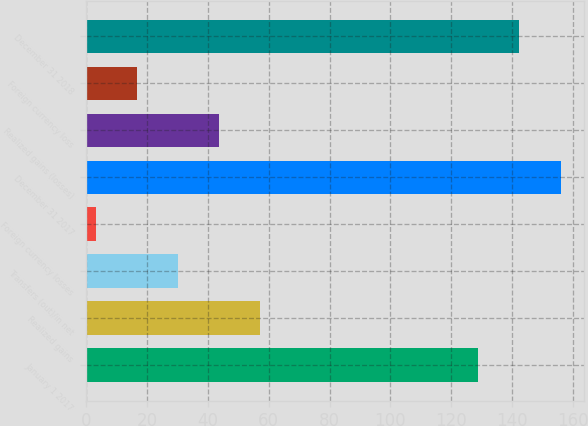Convert chart to OTSL. <chart><loc_0><loc_0><loc_500><loc_500><bar_chart><fcel>January 1 2017<fcel>Realized gains<fcel>Transfers (out)/in net<fcel>Foreign currency losses<fcel>December 31 2017<fcel>Realized gains (losses)<fcel>Foreign currency loss<fcel>December 31 2018<nl><fcel>129<fcel>57<fcel>30<fcel>3<fcel>156<fcel>43.5<fcel>16.5<fcel>142.5<nl></chart> 